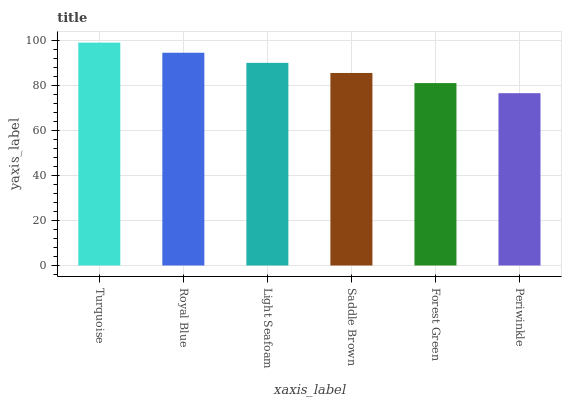Is Periwinkle the minimum?
Answer yes or no. Yes. Is Turquoise the maximum?
Answer yes or no. Yes. Is Royal Blue the minimum?
Answer yes or no. No. Is Royal Blue the maximum?
Answer yes or no. No. Is Turquoise greater than Royal Blue?
Answer yes or no. Yes. Is Royal Blue less than Turquoise?
Answer yes or no. Yes. Is Royal Blue greater than Turquoise?
Answer yes or no. No. Is Turquoise less than Royal Blue?
Answer yes or no. No. Is Light Seafoam the high median?
Answer yes or no. Yes. Is Saddle Brown the low median?
Answer yes or no. Yes. Is Turquoise the high median?
Answer yes or no. No. Is Periwinkle the low median?
Answer yes or no. No. 